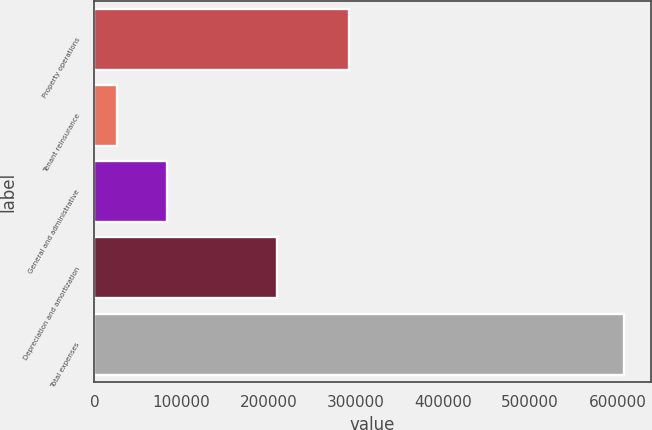<chart> <loc_0><loc_0><loc_500><loc_500><bar_chart><fcel>Property operations<fcel>Tenant reinsurance<fcel>General and administrative<fcel>Depreciation and amortization<fcel>Total expenses<nl><fcel>291695<fcel>25707<fcel>83907.1<fcel>209050<fcel>607708<nl></chart> 